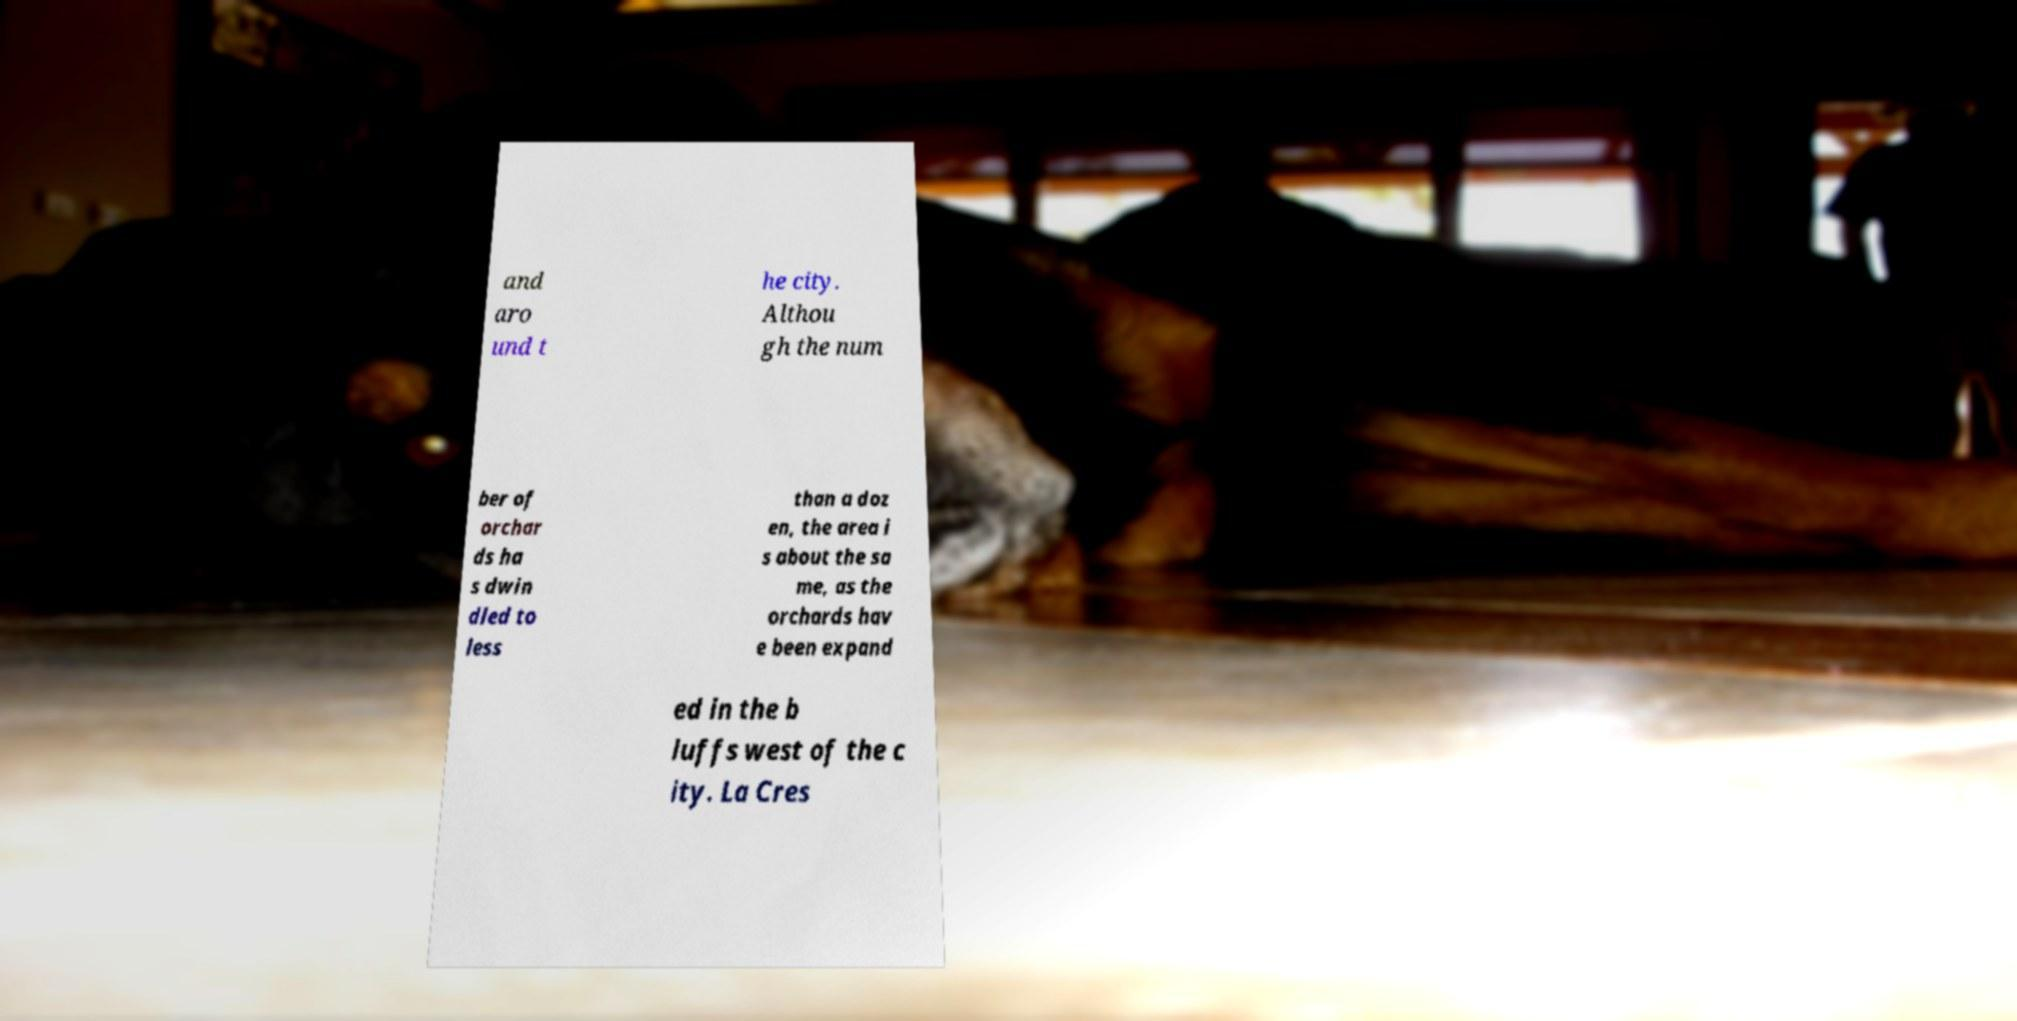What messages or text are displayed in this image? I need them in a readable, typed format. and aro und t he city. Althou gh the num ber of orchar ds ha s dwin dled to less than a doz en, the area i s about the sa me, as the orchards hav e been expand ed in the b luffs west of the c ity. La Cres 